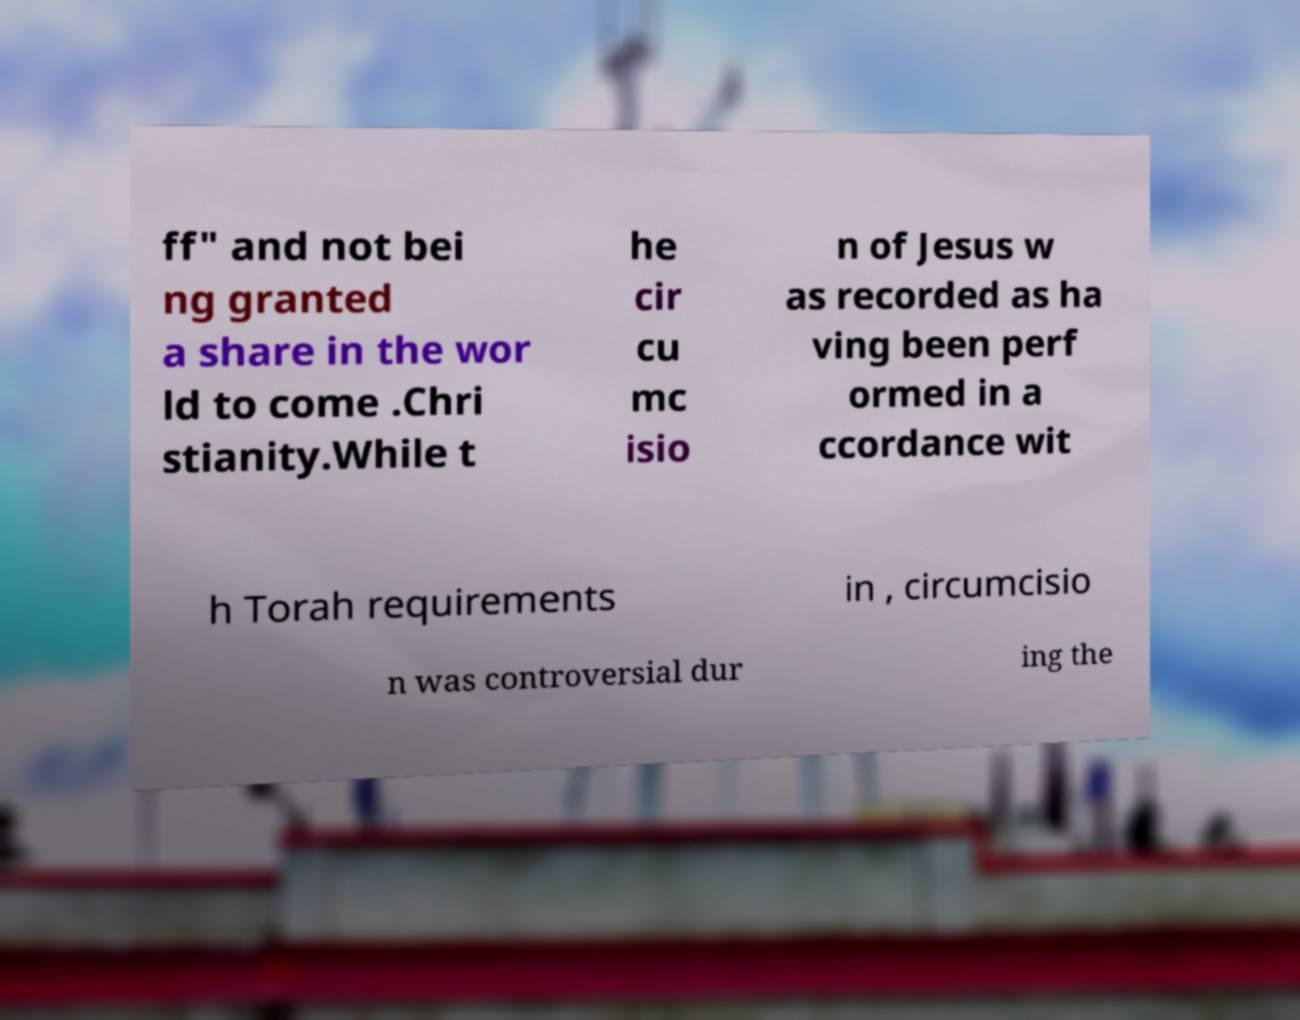What messages or text are displayed in this image? I need them in a readable, typed format. ff" and not bei ng granted a share in the wor ld to come .Chri stianity.While t he cir cu mc isio n of Jesus w as recorded as ha ving been perf ormed in a ccordance wit h Torah requirements in , circumcisio n was controversial dur ing the 